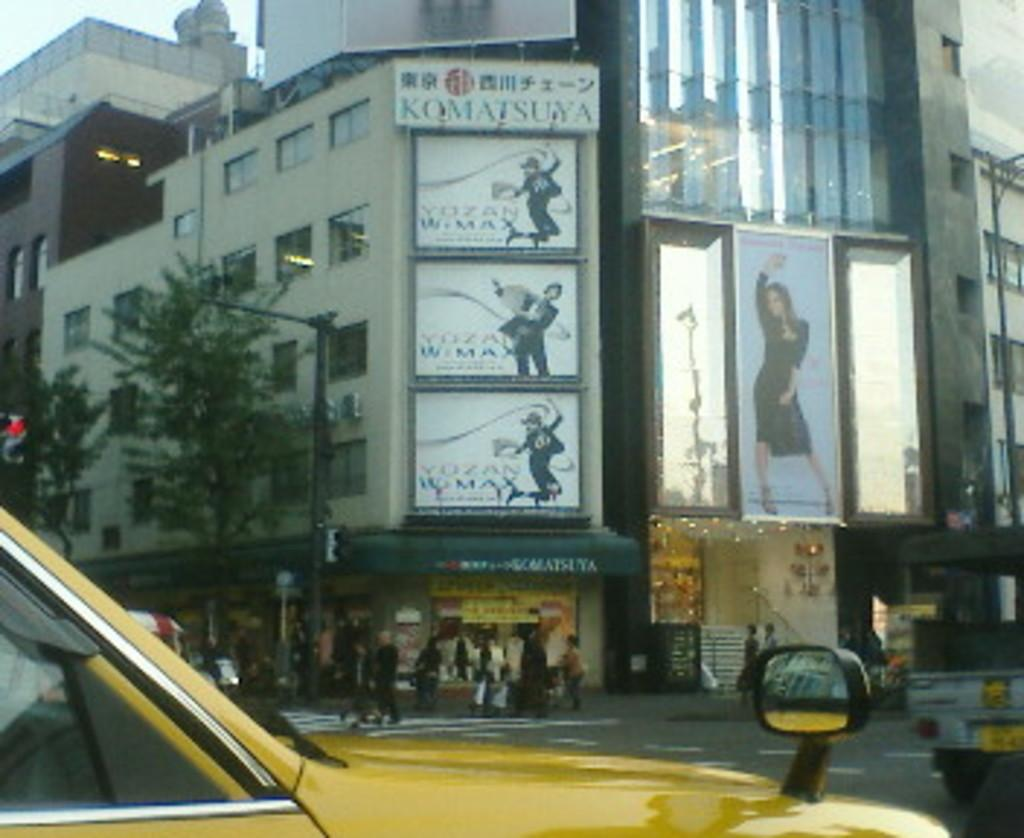<image>
Render a clear and concise summary of the photo. A yellow vehicle in front of some signs, one of which reads Komatsuya 